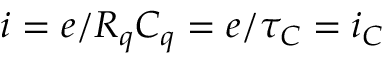<formula> <loc_0><loc_0><loc_500><loc_500>i = e / R _ { q } C _ { q } = e / \tau _ { C } = i _ { C }</formula> 